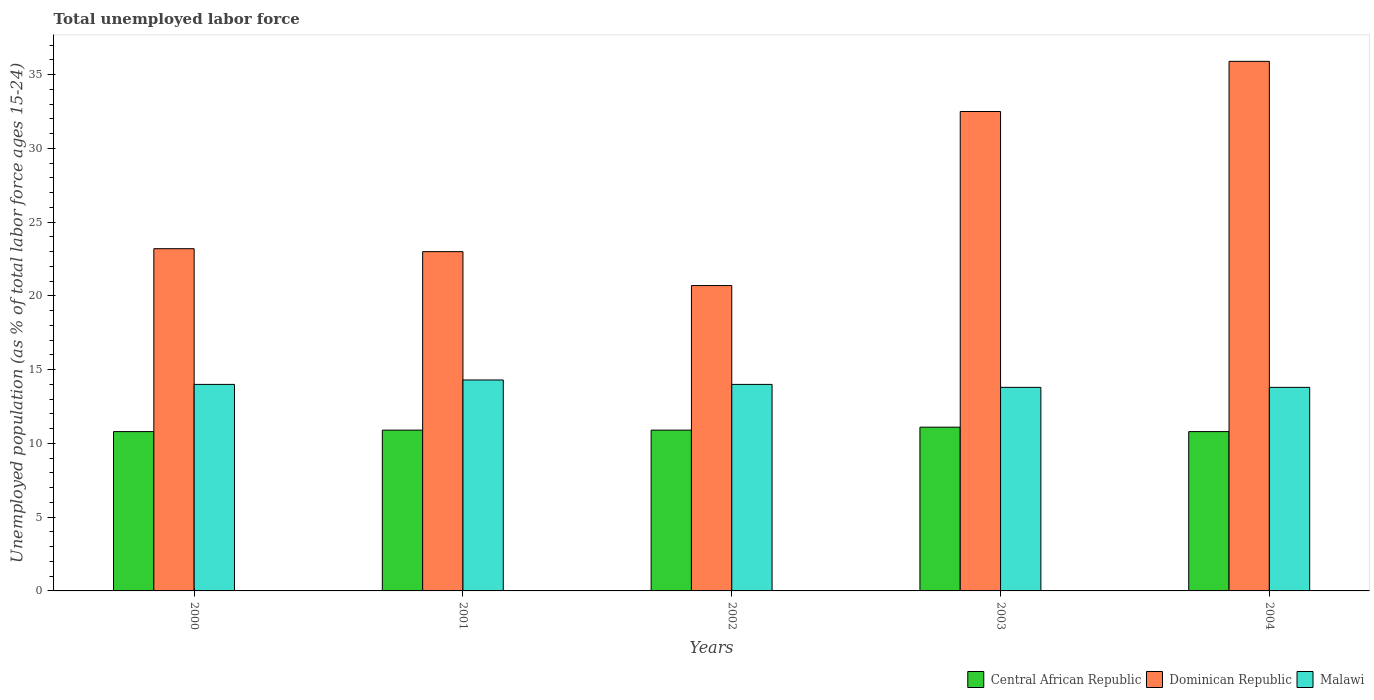How many different coloured bars are there?
Offer a very short reply. 3. How many groups of bars are there?
Give a very brief answer. 5. Are the number of bars per tick equal to the number of legend labels?
Give a very brief answer. Yes. Are the number of bars on each tick of the X-axis equal?
Your response must be concise. Yes. How many bars are there on the 4th tick from the left?
Ensure brevity in your answer.  3. In how many cases, is the number of bars for a given year not equal to the number of legend labels?
Keep it short and to the point. 0. What is the percentage of unemployed population in in Dominican Republic in 2000?
Your answer should be very brief. 23.2. Across all years, what is the maximum percentage of unemployed population in in Central African Republic?
Keep it short and to the point. 11.1. Across all years, what is the minimum percentage of unemployed population in in Malawi?
Offer a very short reply. 13.8. What is the total percentage of unemployed population in in Central African Republic in the graph?
Offer a very short reply. 54.5. What is the difference between the percentage of unemployed population in in Malawi in 2000 and that in 2001?
Provide a succinct answer. -0.3. What is the difference between the percentage of unemployed population in in Dominican Republic in 2003 and the percentage of unemployed population in in Central African Republic in 2002?
Ensure brevity in your answer.  21.6. What is the average percentage of unemployed population in in Central African Republic per year?
Provide a succinct answer. 10.9. In the year 2002, what is the difference between the percentage of unemployed population in in Central African Republic and percentage of unemployed population in in Dominican Republic?
Keep it short and to the point. -9.8. In how many years, is the percentage of unemployed population in in Dominican Republic greater than 20 %?
Keep it short and to the point. 5. What is the ratio of the percentage of unemployed population in in Central African Republic in 2001 to that in 2004?
Make the answer very short. 1.01. Is the percentage of unemployed population in in Dominican Republic in 2000 less than that in 2002?
Provide a succinct answer. No. Is the difference between the percentage of unemployed population in in Central African Republic in 2001 and 2003 greater than the difference between the percentage of unemployed population in in Dominican Republic in 2001 and 2003?
Make the answer very short. Yes. What is the difference between the highest and the second highest percentage of unemployed population in in Malawi?
Give a very brief answer. 0.3. What is the difference between the highest and the lowest percentage of unemployed population in in Central African Republic?
Offer a terse response. 0.3. In how many years, is the percentage of unemployed population in in Malawi greater than the average percentage of unemployed population in in Malawi taken over all years?
Ensure brevity in your answer.  3. What does the 3rd bar from the left in 2002 represents?
Provide a succinct answer. Malawi. What does the 1st bar from the right in 2000 represents?
Provide a short and direct response. Malawi. Is it the case that in every year, the sum of the percentage of unemployed population in in Dominican Republic and percentage of unemployed population in in Malawi is greater than the percentage of unemployed population in in Central African Republic?
Keep it short and to the point. Yes. Are all the bars in the graph horizontal?
Offer a very short reply. No. How many years are there in the graph?
Provide a short and direct response. 5. What is the difference between two consecutive major ticks on the Y-axis?
Your answer should be very brief. 5. Are the values on the major ticks of Y-axis written in scientific E-notation?
Provide a succinct answer. No. Does the graph contain any zero values?
Your response must be concise. No. Does the graph contain grids?
Ensure brevity in your answer.  No. How are the legend labels stacked?
Provide a succinct answer. Horizontal. What is the title of the graph?
Your answer should be compact. Total unemployed labor force. Does "Europe(all income levels)" appear as one of the legend labels in the graph?
Give a very brief answer. No. What is the label or title of the X-axis?
Offer a terse response. Years. What is the label or title of the Y-axis?
Your answer should be very brief. Unemployed population (as % of total labor force ages 15-24). What is the Unemployed population (as % of total labor force ages 15-24) of Central African Republic in 2000?
Keep it short and to the point. 10.8. What is the Unemployed population (as % of total labor force ages 15-24) of Dominican Republic in 2000?
Give a very brief answer. 23.2. What is the Unemployed population (as % of total labor force ages 15-24) of Central African Republic in 2001?
Make the answer very short. 10.9. What is the Unemployed population (as % of total labor force ages 15-24) of Malawi in 2001?
Ensure brevity in your answer.  14.3. What is the Unemployed population (as % of total labor force ages 15-24) in Central African Republic in 2002?
Provide a short and direct response. 10.9. What is the Unemployed population (as % of total labor force ages 15-24) of Dominican Republic in 2002?
Offer a very short reply. 20.7. What is the Unemployed population (as % of total labor force ages 15-24) of Central African Republic in 2003?
Provide a short and direct response. 11.1. What is the Unemployed population (as % of total labor force ages 15-24) of Dominican Republic in 2003?
Ensure brevity in your answer.  32.5. What is the Unemployed population (as % of total labor force ages 15-24) of Malawi in 2003?
Your answer should be compact. 13.8. What is the Unemployed population (as % of total labor force ages 15-24) in Central African Republic in 2004?
Provide a succinct answer. 10.8. What is the Unemployed population (as % of total labor force ages 15-24) in Dominican Republic in 2004?
Your answer should be compact. 35.9. What is the Unemployed population (as % of total labor force ages 15-24) in Malawi in 2004?
Your answer should be very brief. 13.8. Across all years, what is the maximum Unemployed population (as % of total labor force ages 15-24) in Central African Republic?
Make the answer very short. 11.1. Across all years, what is the maximum Unemployed population (as % of total labor force ages 15-24) in Dominican Republic?
Offer a very short reply. 35.9. Across all years, what is the maximum Unemployed population (as % of total labor force ages 15-24) in Malawi?
Your response must be concise. 14.3. Across all years, what is the minimum Unemployed population (as % of total labor force ages 15-24) of Central African Republic?
Make the answer very short. 10.8. Across all years, what is the minimum Unemployed population (as % of total labor force ages 15-24) of Dominican Republic?
Keep it short and to the point. 20.7. Across all years, what is the minimum Unemployed population (as % of total labor force ages 15-24) in Malawi?
Give a very brief answer. 13.8. What is the total Unemployed population (as % of total labor force ages 15-24) of Central African Republic in the graph?
Ensure brevity in your answer.  54.5. What is the total Unemployed population (as % of total labor force ages 15-24) in Dominican Republic in the graph?
Make the answer very short. 135.3. What is the total Unemployed population (as % of total labor force ages 15-24) in Malawi in the graph?
Give a very brief answer. 69.9. What is the difference between the Unemployed population (as % of total labor force ages 15-24) of Malawi in 2000 and that in 2001?
Your response must be concise. -0.3. What is the difference between the Unemployed population (as % of total labor force ages 15-24) of Malawi in 2000 and that in 2002?
Provide a succinct answer. 0. What is the difference between the Unemployed population (as % of total labor force ages 15-24) in Central African Republic in 2000 and that in 2003?
Give a very brief answer. -0.3. What is the difference between the Unemployed population (as % of total labor force ages 15-24) of Malawi in 2000 and that in 2003?
Make the answer very short. 0.2. What is the difference between the Unemployed population (as % of total labor force ages 15-24) in Central African Republic in 2000 and that in 2004?
Your response must be concise. 0. What is the difference between the Unemployed population (as % of total labor force ages 15-24) in Dominican Republic in 2000 and that in 2004?
Offer a terse response. -12.7. What is the difference between the Unemployed population (as % of total labor force ages 15-24) in Central African Republic in 2001 and that in 2002?
Offer a very short reply. 0. What is the difference between the Unemployed population (as % of total labor force ages 15-24) in Malawi in 2001 and that in 2002?
Provide a succinct answer. 0.3. What is the difference between the Unemployed population (as % of total labor force ages 15-24) in Malawi in 2001 and that in 2003?
Give a very brief answer. 0.5. What is the difference between the Unemployed population (as % of total labor force ages 15-24) of Central African Republic in 2001 and that in 2004?
Give a very brief answer. 0.1. What is the difference between the Unemployed population (as % of total labor force ages 15-24) of Dominican Republic in 2001 and that in 2004?
Provide a succinct answer. -12.9. What is the difference between the Unemployed population (as % of total labor force ages 15-24) of Dominican Republic in 2002 and that in 2003?
Provide a succinct answer. -11.8. What is the difference between the Unemployed population (as % of total labor force ages 15-24) in Central African Republic in 2002 and that in 2004?
Offer a terse response. 0.1. What is the difference between the Unemployed population (as % of total labor force ages 15-24) of Dominican Republic in 2002 and that in 2004?
Provide a short and direct response. -15.2. What is the difference between the Unemployed population (as % of total labor force ages 15-24) in Malawi in 2002 and that in 2004?
Your answer should be compact. 0.2. What is the difference between the Unemployed population (as % of total labor force ages 15-24) of Dominican Republic in 2003 and that in 2004?
Your answer should be compact. -3.4. What is the difference between the Unemployed population (as % of total labor force ages 15-24) in Malawi in 2003 and that in 2004?
Give a very brief answer. 0. What is the difference between the Unemployed population (as % of total labor force ages 15-24) in Dominican Republic in 2000 and the Unemployed population (as % of total labor force ages 15-24) in Malawi in 2001?
Your response must be concise. 8.9. What is the difference between the Unemployed population (as % of total labor force ages 15-24) of Central African Republic in 2000 and the Unemployed population (as % of total labor force ages 15-24) of Dominican Republic in 2002?
Offer a very short reply. -9.9. What is the difference between the Unemployed population (as % of total labor force ages 15-24) of Central African Republic in 2000 and the Unemployed population (as % of total labor force ages 15-24) of Malawi in 2002?
Your answer should be compact. -3.2. What is the difference between the Unemployed population (as % of total labor force ages 15-24) of Central African Republic in 2000 and the Unemployed population (as % of total labor force ages 15-24) of Dominican Republic in 2003?
Your answer should be very brief. -21.7. What is the difference between the Unemployed population (as % of total labor force ages 15-24) in Central African Republic in 2000 and the Unemployed population (as % of total labor force ages 15-24) in Malawi in 2003?
Provide a succinct answer. -3. What is the difference between the Unemployed population (as % of total labor force ages 15-24) in Central African Republic in 2000 and the Unemployed population (as % of total labor force ages 15-24) in Dominican Republic in 2004?
Ensure brevity in your answer.  -25.1. What is the difference between the Unemployed population (as % of total labor force ages 15-24) in Dominican Republic in 2000 and the Unemployed population (as % of total labor force ages 15-24) in Malawi in 2004?
Your answer should be compact. 9.4. What is the difference between the Unemployed population (as % of total labor force ages 15-24) of Central African Republic in 2001 and the Unemployed population (as % of total labor force ages 15-24) of Dominican Republic in 2002?
Provide a short and direct response. -9.8. What is the difference between the Unemployed population (as % of total labor force ages 15-24) in Dominican Republic in 2001 and the Unemployed population (as % of total labor force ages 15-24) in Malawi in 2002?
Provide a succinct answer. 9. What is the difference between the Unemployed population (as % of total labor force ages 15-24) of Central African Republic in 2001 and the Unemployed population (as % of total labor force ages 15-24) of Dominican Republic in 2003?
Provide a short and direct response. -21.6. What is the difference between the Unemployed population (as % of total labor force ages 15-24) of Central African Republic in 2002 and the Unemployed population (as % of total labor force ages 15-24) of Dominican Republic in 2003?
Offer a terse response. -21.6. What is the difference between the Unemployed population (as % of total labor force ages 15-24) in Dominican Republic in 2002 and the Unemployed population (as % of total labor force ages 15-24) in Malawi in 2003?
Offer a very short reply. 6.9. What is the difference between the Unemployed population (as % of total labor force ages 15-24) of Central African Republic in 2002 and the Unemployed population (as % of total labor force ages 15-24) of Dominican Republic in 2004?
Ensure brevity in your answer.  -25. What is the difference between the Unemployed population (as % of total labor force ages 15-24) of Dominican Republic in 2002 and the Unemployed population (as % of total labor force ages 15-24) of Malawi in 2004?
Your answer should be very brief. 6.9. What is the difference between the Unemployed population (as % of total labor force ages 15-24) of Central African Republic in 2003 and the Unemployed population (as % of total labor force ages 15-24) of Dominican Republic in 2004?
Provide a short and direct response. -24.8. What is the difference between the Unemployed population (as % of total labor force ages 15-24) of Central African Republic in 2003 and the Unemployed population (as % of total labor force ages 15-24) of Malawi in 2004?
Offer a very short reply. -2.7. What is the difference between the Unemployed population (as % of total labor force ages 15-24) of Dominican Republic in 2003 and the Unemployed population (as % of total labor force ages 15-24) of Malawi in 2004?
Give a very brief answer. 18.7. What is the average Unemployed population (as % of total labor force ages 15-24) of Dominican Republic per year?
Offer a terse response. 27.06. What is the average Unemployed population (as % of total labor force ages 15-24) in Malawi per year?
Provide a succinct answer. 13.98. In the year 2000, what is the difference between the Unemployed population (as % of total labor force ages 15-24) in Central African Republic and Unemployed population (as % of total labor force ages 15-24) in Malawi?
Provide a succinct answer. -3.2. In the year 2000, what is the difference between the Unemployed population (as % of total labor force ages 15-24) of Dominican Republic and Unemployed population (as % of total labor force ages 15-24) of Malawi?
Your response must be concise. 9.2. In the year 2001, what is the difference between the Unemployed population (as % of total labor force ages 15-24) in Dominican Republic and Unemployed population (as % of total labor force ages 15-24) in Malawi?
Provide a short and direct response. 8.7. In the year 2002, what is the difference between the Unemployed population (as % of total labor force ages 15-24) in Central African Republic and Unemployed population (as % of total labor force ages 15-24) in Malawi?
Keep it short and to the point. -3.1. In the year 2002, what is the difference between the Unemployed population (as % of total labor force ages 15-24) of Dominican Republic and Unemployed population (as % of total labor force ages 15-24) of Malawi?
Your answer should be compact. 6.7. In the year 2003, what is the difference between the Unemployed population (as % of total labor force ages 15-24) in Central African Republic and Unemployed population (as % of total labor force ages 15-24) in Dominican Republic?
Ensure brevity in your answer.  -21.4. In the year 2003, what is the difference between the Unemployed population (as % of total labor force ages 15-24) of Central African Republic and Unemployed population (as % of total labor force ages 15-24) of Malawi?
Your answer should be very brief. -2.7. In the year 2004, what is the difference between the Unemployed population (as % of total labor force ages 15-24) of Central African Republic and Unemployed population (as % of total labor force ages 15-24) of Dominican Republic?
Give a very brief answer. -25.1. In the year 2004, what is the difference between the Unemployed population (as % of total labor force ages 15-24) of Central African Republic and Unemployed population (as % of total labor force ages 15-24) of Malawi?
Keep it short and to the point. -3. In the year 2004, what is the difference between the Unemployed population (as % of total labor force ages 15-24) in Dominican Republic and Unemployed population (as % of total labor force ages 15-24) in Malawi?
Make the answer very short. 22.1. What is the ratio of the Unemployed population (as % of total labor force ages 15-24) of Central African Republic in 2000 to that in 2001?
Keep it short and to the point. 0.99. What is the ratio of the Unemployed population (as % of total labor force ages 15-24) of Dominican Republic in 2000 to that in 2001?
Keep it short and to the point. 1.01. What is the ratio of the Unemployed population (as % of total labor force ages 15-24) of Central African Republic in 2000 to that in 2002?
Keep it short and to the point. 0.99. What is the ratio of the Unemployed population (as % of total labor force ages 15-24) of Dominican Republic in 2000 to that in 2002?
Offer a terse response. 1.12. What is the ratio of the Unemployed population (as % of total labor force ages 15-24) of Central African Republic in 2000 to that in 2003?
Offer a terse response. 0.97. What is the ratio of the Unemployed population (as % of total labor force ages 15-24) of Dominican Republic in 2000 to that in 2003?
Ensure brevity in your answer.  0.71. What is the ratio of the Unemployed population (as % of total labor force ages 15-24) in Malawi in 2000 to that in 2003?
Provide a short and direct response. 1.01. What is the ratio of the Unemployed population (as % of total labor force ages 15-24) of Dominican Republic in 2000 to that in 2004?
Offer a very short reply. 0.65. What is the ratio of the Unemployed population (as % of total labor force ages 15-24) of Malawi in 2000 to that in 2004?
Your response must be concise. 1.01. What is the ratio of the Unemployed population (as % of total labor force ages 15-24) in Central African Republic in 2001 to that in 2002?
Your answer should be very brief. 1. What is the ratio of the Unemployed population (as % of total labor force ages 15-24) of Dominican Republic in 2001 to that in 2002?
Offer a very short reply. 1.11. What is the ratio of the Unemployed population (as % of total labor force ages 15-24) in Malawi in 2001 to that in 2002?
Provide a short and direct response. 1.02. What is the ratio of the Unemployed population (as % of total labor force ages 15-24) of Central African Republic in 2001 to that in 2003?
Provide a succinct answer. 0.98. What is the ratio of the Unemployed population (as % of total labor force ages 15-24) of Dominican Republic in 2001 to that in 2003?
Keep it short and to the point. 0.71. What is the ratio of the Unemployed population (as % of total labor force ages 15-24) of Malawi in 2001 to that in 2003?
Your answer should be compact. 1.04. What is the ratio of the Unemployed population (as % of total labor force ages 15-24) in Central African Republic in 2001 to that in 2004?
Provide a short and direct response. 1.01. What is the ratio of the Unemployed population (as % of total labor force ages 15-24) in Dominican Republic in 2001 to that in 2004?
Give a very brief answer. 0.64. What is the ratio of the Unemployed population (as % of total labor force ages 15-24) in Malawi in 2001 to that in 2004?
Offer a terse response. 1.04. What is the ratio of the Unemployed population (as % of total labor force ages 15-24) in Central African Republic in 2002 to that in 2003?
Make the answer very short. 0.98. What is the ratio of the Unemployed population (as % of total labor force ages 15-24) of Dominican Republic in 2002 to that in 2003?
Provide a short and direct response. 0.64. What is the ratio of the Unemployed population (as % of total labor force ages 15-24) of Malawi in 2002 to that in 2003?
Offer a terse response. 1.01. What is the ratio of the Unemployed population (as % of total labor force ages 15-24) in Central African Republic in 2002 to that in 2004?
Your response must be concise. 1.01. What is the ratio of the Unemployed population (as % of total labor force ages 15-24) of Dominican Republic in 2002 to that in 2004?
Give a very brief answer. 0.58. What is the ratio of the Unemployed population (as % of total labor force ages 15-24) of Malawi in 2002 to that in 2004?
Your response must be concise. 1.01. What is the ratio of the Unemployed population (as % of total labor force ages 15-24) in Central African Republic in 2003 to that in 2004?
Your response must be concise. 1.03. What is the ratio of the Unemployed population (as % of total labor force ages 15-24) of Dominican Republic in 2003 to that in 2004?
Give a very brief answer. 0.91. What is the ratio of the Unemployed population (as % of total labor force ages 15-24) of Malawi in 2003 to that in 2004?
Ensure brevity in your answer.  1. What is the difference between the highest and the lowest Unemployed population (as % of total labor force ages 15-24) of Malawi?
Make the answer very short. 0.5. 